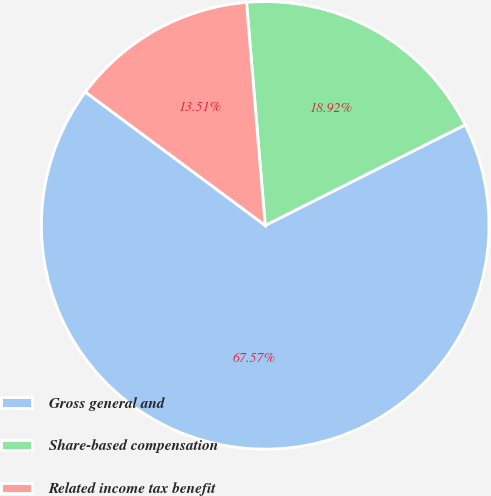Convert chart. <chart><loc_0><loc_0><loc_500><loc_500><pie_chart><fcel>Gross general and<fcel>Share-based compensation<fcel>Related income tax benefit<nl><fcel>67.57%<fcel>18.92%<fcel>13.51%<nl></chart> 